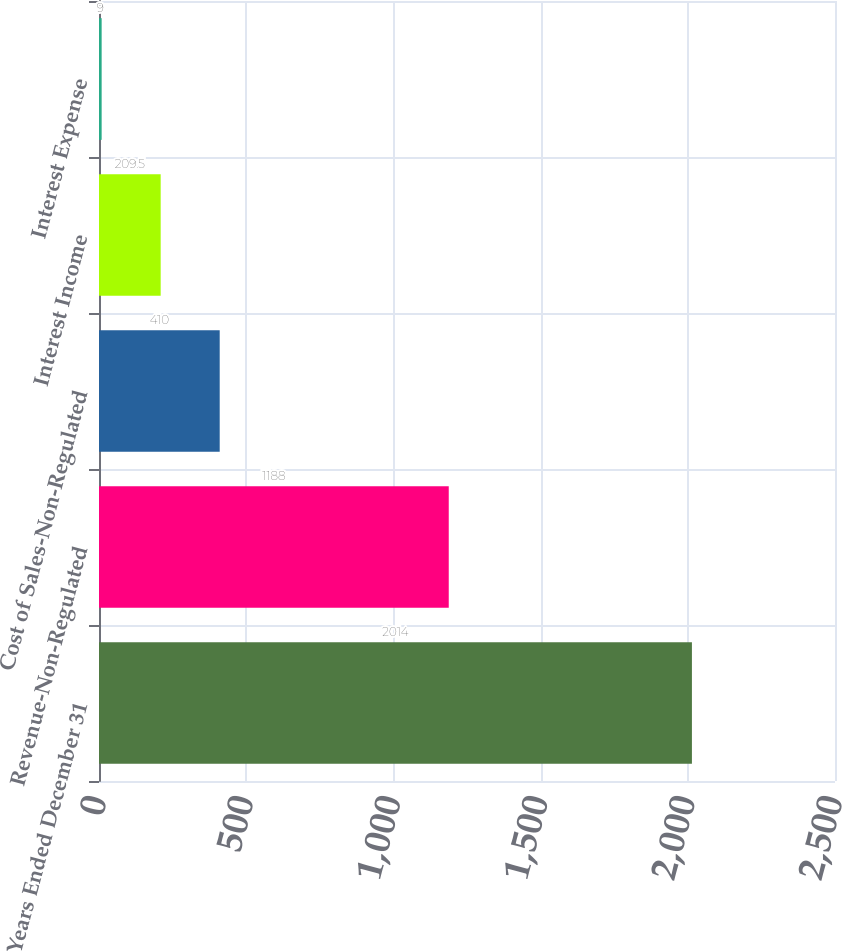Convert chart. <chart><loc_0><loc_0><loc_500><loc_500><bar_chart><fcel>Years Ended December 31<fcel>Revenue-Non-Regulated<fcel>Cost of Sales-Non-Regulated<fcel>Interest Income<fcel>Interest Expense<nl><fcel>2014<fcel>1188<fcel>410<fcel>209.5<fcel>9<nl></chart> 